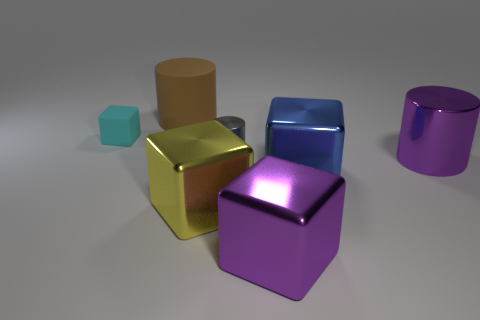Are there any small cyan things behind the large brown rubber object?
Give a very brief answer. No. Is the number of purple cylinders greater than the number of large yellow matte cubes?
Offer a very short reply. Yes. There is a large cylinder right of the purple metallic thing that is in front of the large cylinder in front of the tiny rubber block; what color is it?
Your answer should be compact. Purple. What color is the other cylinder that is made of the same material as the gray cylinder?
Ensure brevity in your answer.  Purple. What number of objects are small things to the right of the big rubber thing or cubes that are on the right side of the small shiny thing?
Offer a very short reply. 3. There is a purple thing in front of the blue block; does it have the same size as the block behind the small shiny cylinder?
Ensure brevity in your answer.  No. What is the color of the tiny shiny thing that is the same shape as the brown rubber object?
Offer a very short reply. Gray. Are there more cylinders behind the tiny shiny thing than large yellow metal things to the right of the blue shiny thing?
Offer a very short reply. Yes. There is a matte thing that is on the right side of the block that is behind the large purple thing that is behind the yellow metal thing; how big is it?
Provide a succinct answer. Large. Does the blue object have the same material as the large cylinder to the left of the big purple cylinder?
Give a very brief answer. No. 